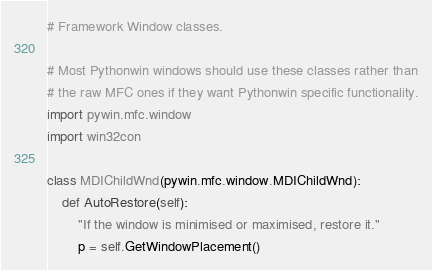Convert code to text. <code><loc_0><loc_0><loc_500><loc_500><_Python_># Framework Window classes.

# Most Pythonwin windows should use these classes rather than
# the raw MFC ones if they want Pythonwin specific functionality.
import pywin.mfc.window
import win32con

class MDIChildWnd(pywin.mfc.window.MDIChildWnd):
	def AutoRestore(self):
		"If the window is minimised or maximised, restore it."
		p = self.GetWindowPlacement()</code> 